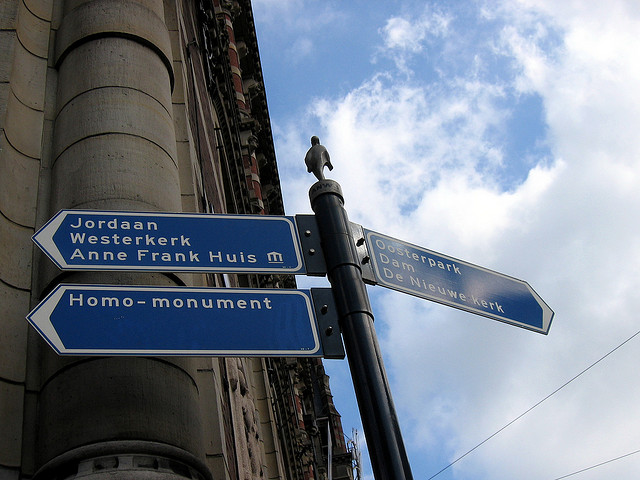Identify and read out the text in this image. Jordan Westerkerk Anne Frank Homo kerk Nieuwe De Dam park Ooster monument Huis 